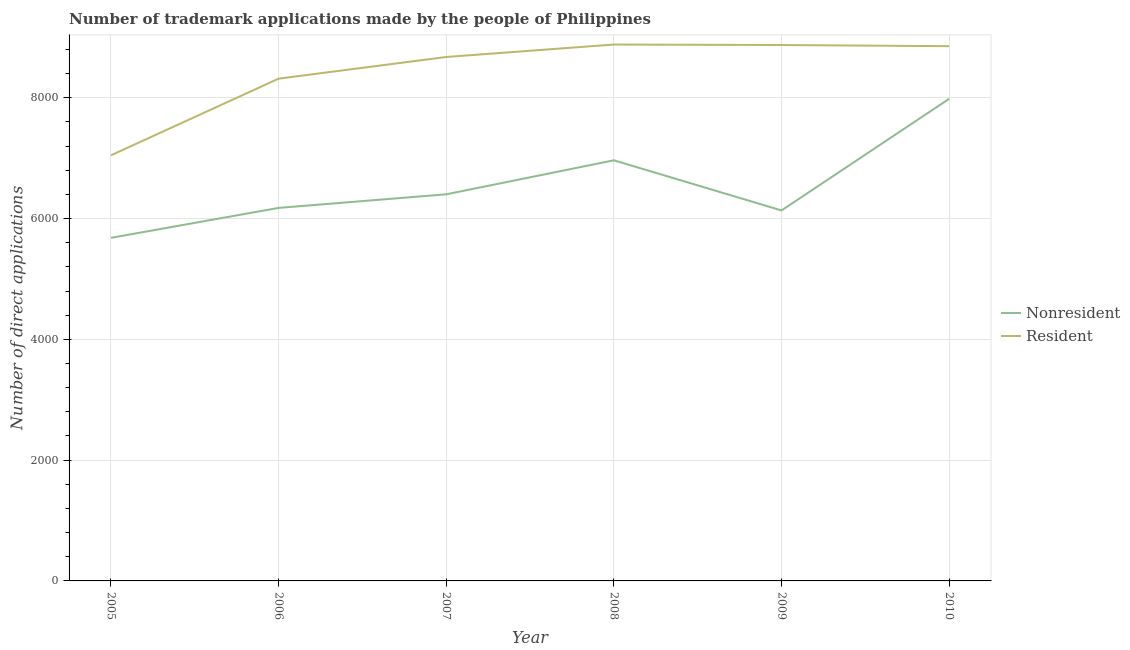How many different coloured lines are there?
Offer a terse response. 2. What is the number of trademark applications made by residents in 2009?
Your answer should be compact. 8874. Across all years, what is the maximum number of trademark applications made by residents?
Your answer should be compact. 8882. Across all years, what is the minimum number of trademark applications made by non residents?
Give a very brief answer. 5681. In which year was the number of trademark applications made by residents maximum?
Offer a terse response. 2008. What is the total number of trademark applications made by non residents in the graph?
Provide a succinct answer. 3.93e+04. What is the difference between the number of trademark applications made by non residents in 2005 and that in 2009?
Provide a short and direct response. -454. What is the difference between the number of trademark applications made by non residents in 2006 and the number of trademark applications made by residents in 2009?
Give a very brief answer. -2697. What is the average number of trademark applications made by non residents per year?
Provide a succinct answer. 6557.17. In the year 2010, what is the difference between the number of trademark applications made by non residents and number of trademark applications made by residents?
Keep it short and to the point. -872. In how many years, is the number of trademark applications made by residents greater than 5200?
Ensure brevity in your answer.  6. What is the ratio of the number of trademark applications made by residents in 2008 to that in 2010?
Offer a very short reply. 1. Is the number of trademark applications made by non residents in 2007 less than that in 2009?
Make the answer very short. No. What is the difference between the highest and the second highest number of trademark applications made by residents?
Offer a terse response. 8. What is the difference between the highest and the lowest number of trademark applications made by residents?
Offer a terse response. 1834. In how many years, is the number of trademark applications made by residents greater than the average number of trademark applications made by residents taken over all years?
Your response must be concise. 4. Does the number of trademark applications made by residents monotonically increase over the years?
Your answer should be compact. No. How many lines are there?
Your answer should be compact. 2. Does the graph contain grids?
Give a very brief answer. Yes. Where does the legend appear in the graph?
Your response must be concise. Center right. How many legend labels are there?
Provide a short and direct response. 2. What is the title of the graph?
Keep it short and to the point. Number of trademark applications made by the people of Philippines. Does "Not attending school" appear as one of the legend labels in the graph?
Your response must be concise. No. What is the label or title of the Y-axis?
Your response must be concise. Number of direct applications. What is the Number of direct applications in Nonresident in 2005?
Provide a succinct answer. 5681. What is the Number of direct applications of Resident in 2005?
Your answer should be very brief. 7048. What is the Number of direct applications of Nonresident in 2006?
Your answer should be compact. 6177. What is the Number of direct applications of Resident in 2006?
Provide a succinct answer. 8317. What is the Number of direct applications of Nonresident in 2007?
Your answer should be compact. 6402. What is the Number of direct applications in Resident in 2007?
Your answer should be compact. 8676. What is the Number of direct applications in Nonresident in 2008?
Ensure brevity in your answer.  6965. What is the Number of direct applications in Resident in 2008?
Offer a very short reply. 8882. What is the Number of direct applications in Nonresident in 2009?
Offer a terse response. 6135. What is the Number of direct applications in Resident in 2009?
Give a very brief answer. 8874. What is the Number of direct applications in Nonresident in 2010?
Ensure brevity in your answer.  7983. What is the Number of direct applications of Resident in 2010?
Give a very brief answer. 8855. Across all years, what is the maximum Number of direct applications of Nonresident?
Offer a terse response. 7983. Across all years, what is the maximum Number of direct applications in Resident?
Keep it short and to the point. 8882. Across all years, what is the minimum Number of direct applications of Nonresident?
Your answer should be very brief. 5681. Across all years, what is the minimum Number of direct applications in Resident?
Provide a succinct answer. 7048. What is the total Number of direct applications of Nonresident in the graph?
Your response must be concise. 3.93e+04. What is the total Number of direct applications of Resident in the graph?
Make the answer very short. 5.07e+04. What is the difference between the Number of direct applications in Nonresident in 2005 and that in 2006?
Your answer should be compact. -496. What is the difference between the Number of direct applications of Resident in 2005 and that in 2006?
Provide a succinct answer. -1269. What is the difference between the Number of direct applications of Nonresident in 2005 and that in 2007?
Offer a terse response. -721. What is the difference between the Number of direct applications of Resident in 2005 and that in 2007?
Offer a very short reply. -1628. What is the difference between the Number of direct applications in Nonresident in 2005 and that in 2008?
Provide a short and direct response. -1284. What is the difference between the Number of direct applications in Resident in 2005 and that in 2008?
Your answer should be compact. -1834. What is the difference between the Number of direct applications of Nonresident in 2005 and that in 2009?
Offer a terse response. -454. What is the difference between the Number of direct applications of Resident in 2005 and that in 2009?
Your response must be concise. -1826. What is the difference between the Number of direct applications of Nonresident in 2005 and that in 2010?
Make the answer very short. -2302. What is the difference between the Number of direct applications in Resident in 2005 and that in 2010?
Keep it short and to the point. -1807. What is the difference between the Number of direct applications of Nonresident in 2006 and that in 2007?
Provide a succinct answer. -225. What is the difference between the Number of direct applications in Resident in 2006 and that in 2007?
Offer a very short reply. -359. What is the difference between the Number of direct applications in Nonresident in 2006 and that in 2008?
Your answer should be compact. -788. What is the difference between the Number of direct applications in Resident in 2006 and that in 2008?
Keep it short and to the point. -565. What is the difference between the Number of direct applications of Nonresident in 2006 and that in 2009?
Ensure brevity in your answer.  42. What is the difference between the Number of direct applications of Resident in 2006 and that in 2009?
Your answer should be compact. -557. What is the difference between the Number of direct applications in Nonresident in 2006 and that in 2010?
Provide a short and direct response. -1806. What is the difference between the Number of direct applications of Resident in 2006 and that in 2010?
Provide a succinct answer. -538. What is the difference between the Number of direct applications of Nonresident in 2007 and that in 2008?
Give a very brief answer. -563. What is the difference between the Number of direct applications of Resident in 2007 and that in 2008?
Your response must be concise. -206. What is the difference between the Number of direct applications of Nonresident in 2007 and that in 2009?
Ensure brevity in your answer.  267. What is the difference between the Number of direct applications of Resident in 2007 and that in 2009?
Make the answer very short. -198. What is the difference between the Number of direct applications of Nonresident in 2007 and that in 2010?
Give a very brief answer. -1581. What is the difference between the Number of direct applications of Resident in 2007 and that in 2010?
Provide a short and direct response. -179. What is the difference between the Number of direct applications of Nonresident in 2008 and that in 2009?
Provide a succinct answer. 830. What is the difference between the Number of direct applications of Nonresident in 2008 and that in 2010?
Keep it short and to the point. -1018. What is the difference between the Number of direct applications in Resident in 2008 and that in 2010?
Keep it short and to the point. 27. What is the difference between the Number of direct applications in Nonresident in 2009 and that in 2010?
Your answer should be very brief. -1848. What is the difference between the Number of direct applications in Resident in 2009 and that in 2010?
Ensure brevity in your answer.  19. What is the difference between the Number of direct applications in Nonresident in 2005 and the Number of direct applications in Resident in 2006?
Your response must be concise. -2636. What is the difference between the Number of direct applications in Nonresident in 2005 and the Number of direct applications in Resident in 2007?
Your response must be concise. -2995. What is the difference between the Number of direct applications of Nonresident in 2005 and the Number of direct applications of Resident in 2008?
Give a very brief answer. -3201. What is the difference between the Number of direct applications in Nonresident in 2005 and the Number of direct applications in Resident in 2009?
Give a very brief answer. -3193. What is the difference between the Number of direct applications in Nonresident in 2005 and the Number of direct applications in Resident in 2010?
Offer a very short reply. -3174. What is the difference between the Number of direct applications of Nonresident in 2006 and the Number of direct applications of Resident in 2007?
Ensure brevity in your answer.  -2499. What is the difference between the Number of direct applications of Nonresident in 2006 and the Number of direct applications of Resident in 2008?
Make the answer very short. -2705. What is the difference between the Number of direct applications of Nonresident in 2006 and the Number of direct applications of Resident in 2009?
Make the answer very short. -2697. What is the difference between the Number of direct applications in Nonresident in 2006 and the Number of direct applications in Resident in 2010?
Your answer should be very brief. -2678. What is the difference between the Number of direct applications in Nonresident in 2007 and the Number of direct applications in Resident in 2008?
Your answer should be compact. -2480. What is the difference between the Number of direct applications of Nonresident in 2007 and the Number of direct applications of Resident in 2009?
Offer a very short reply. -2472. What is the difference between the Number of direct applications in Nonresident in 2007 and the Number of direct applications in Resident in 2010?
Keep it short and to the point. -2453. What is the difference between the Number of direct applications in Nonresident in 2008 and the Number of direct applications in Resident in 2009?
Keep it short and to the point. -1909. What is the difference between the Number of direct applications of Nonresident in 2008 and the Number of direct applications of Resident in 2010?
Offer a terse response. -1890. What is the difference between the Number of direct applications of Nonresident in 2009 and the Number of direct applications of Resident in 2010?
Your response must be concise. -2720. What is the average Number of direct applications of Nonresident per year?
Your answer should be very brief. 6557.17. What is the average Number of direct applications of Resident per year?
Give a very brief answer. 8442. In the year 2005, what is the difference between the Number of direct applications in Nonresident and Number of direct applications in Resident?
Offer a terse response. -1367. In the year 2006, what is the difference between the Number of direct applications of Nonresident and Number of direct applications of Resident?
Offer a very short reply. -2140. In the year 2007, what is the difference between the Number of direct applications of Nonresident and Number of direct applications of Resident?
Offer a very short reply. -2274. In the year 2008, what is the difference between the Number of direct applications of Nonresident and Number of direct applications of Resident?
Give a very brief answer. -1917. In the year 2009, what is the difference between the Number of direct applications of Nonresident and Number of direct applications of Resident?
Provide a short and direct response. -2739. In the year 2010, what is the difference between the Number of direct applications of Nonresident and Number of direct applications of Resident?
Give a very brief answer. -872. What is the ratio of the Number of direct applications of Nonresident in 2005 to that in 2006?
Keep it short and to the point. 0.92. What is the ratio of the Number of direct applications of Resident in 2005 to that in 2006?
Offer a terse response. 0.85. What is the ratio of the Number of direct applications in Nonresident in 2005 to that in 2007?
Keep it short and to the point. 0.89. What is the ratio of the Number of direct applications of Resident in 2005 to that in 2007?
Keep it short and to the point. 0.81. What is the ratio of the Number of direct applications in Nonresident in 2005 to that in 2008?
Keep it short and to the point. 0.82. What is the ratio of the Number of direct applications in Resident in 2005 to that in 2008?
Ensure brevity in your answer.  0.79. What is the ratio of the Number of direct applications of Nonresident in 2005 to that in 2009?
Provide a succinct answer. 0.93. What is the ratio of the Number of direct applications in Resident in 2005 to that in 2009?
Provide a succinct answer. 0.79. What is the ratio of the Number of direct applications in Nonresident in 2005 to that in 2010?
Make the answer very short. 0.71. What is the ratio of the Number of direct applications in Resident in 2005 to that in 2010?
Give a very brief answer. 0.8. What is the ratio of the Number of direct applications of Nonresident in 2006 to that in 2007?
Your answer should be very brief. 0.96. What is the ratio of the Number of direct applications of Resident in 2006 to that in 2007?
Give a very brief answer. 0.96. What is the ratio of the Number of direct applications in Nonresident in 2006 to that in 2008?
Provide a short and direct response. 0.89. What is the ratio of the Number of direct applications of Resident in 2006 to that in 2008?
Ensure brevity in your answer.  0.94. What is the ratio of the Number of direct applications in Nonresident in 2006 to that in 2009?
Provide a short and direct response. 1.01. What is the ratio of the Number of direct applications in Resident in 2006 to that in 2009?
Provide a short and direct response. 0.94. What is the ratio of the Number of direct applications in Nonresident in 2006 to that in 2010?
Offer a terse response. 0.77. What is the ratio of the Number of direct applications of Resident in 2006 to that in 2010?
Your answer should be compact. 0.94. What is the ratio of the Number of direct applications in Nonresident in 2007 to that in 2008?
Make the answer very short. 0.92. What is the ratio of the Number of direct applications of Resident in 2007 to that in 2008?
Offer a terse response. 0.98. What is the ratio of the Number of direct applications in Nonresident in 2007 to that in 2009?
Offer a very short reply. 1.04. What is the ratio of the Number of direct applications of Resident in 2007 to that in 2009?
Give a very brief answer. 0.98. What is the ratio of the Number of direct applications of Nonresident in 2007 to that in 2010?
Give a very brief answer. 0.8. What is the ratio of the Number of direct applications of Resident in 2007 to that in 2010?
Offer a terse response. 0.98. What is the ratio of the Number of direct applications in Nonresident in 2008 to that in 2009?
Offer a very short reply. 1.14. What is the ratio of the Number of direct applications in Nonresident in 2008 to that in 2010?
Provide a succinct answer. 0.87. What is the ratio of the Number of direct applications of Nonresident in 2009 to that in 2010?
Your answer should be compact. 0.77. What is the ratio of the Number of direct applications in Resident in 2009 to that in 2010?
Provide a succinct answer. 1. What is the difference between the highest and the second highest Number of direct applications in Nonresident?
Your answer should be compact. 1018. What is the difference between the highest and the second highest Number of direct applications in Resident?
Ensure brevity in your answer.  8. What is the difference between the highest and the lowest Number of direct applications in Nonresident?
Provide a short and direct response. 2302. What is the difference between the highest and the lowest Number of direct applications of Resident?
Your answer should be compact. 1834. 